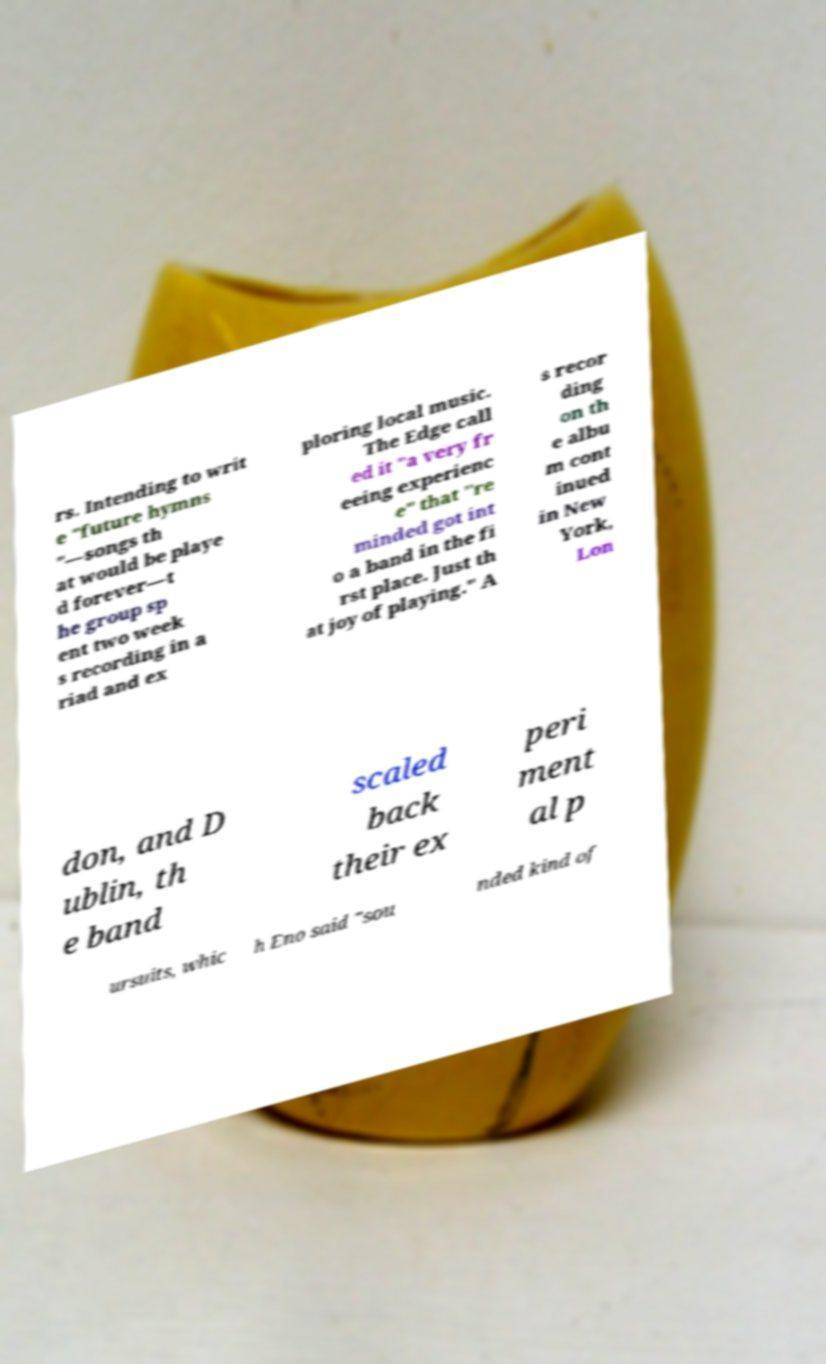Could you extract and type out the text from this image? rs. Intending to writ e "future hymns "—songs th at would be playe d forever—t he group sp ent two week s recording in a riad and ex ploring local music. The Edge call ed it "a very fr eeing experienc e" that "re minded got int o a band in the fi rst place. Just th at joy of playing." A s recor ding on th e albu m cont inued in New York, Lon don, and D ublin, th e band scaled back their ex peri ment al p ursuits, whic h Eno said "sou nded kind of 